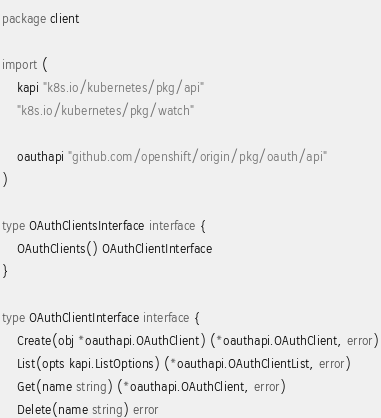<code> <loc_0><loc_0><loc_500><loc_500><_Go_>package client

import (
	kapi "k8s.io/kubernetes/pkg/api"
	"k8s.io/kubernetes/pkg/watch"

	oauthapi "github.com/openshift/origin/pkg/oauth/api"
)

type OAuthClientsInterface interface {
	OAuthClients() OAuthClientInterface
}

type OAuthClientInterface interface {
	Create(obj *oauthapi.OAuthClient) (*oauthapi.OAuthClient, error)
	List(opts kapi.ListOptions) (*oauthapi.OAuthClientList, error)
	Get(name string) (*oauthapi.OAuthClient, error)
	Delete(name string) error</code> 